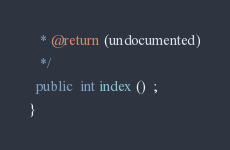Convert code to text. <code><loc_0><loc_0><loc_500><loc_500><_Java_>   * @return (undocumented)
   */
  public  int index ()  ;
}
</code> 